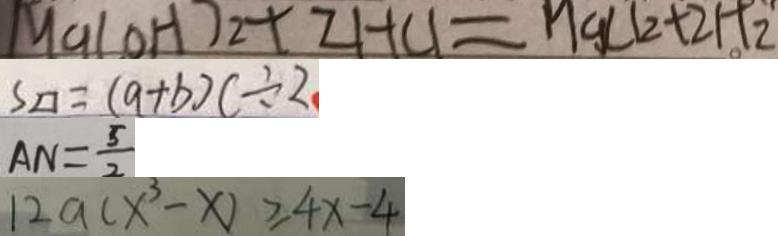<formula> <loc_0><loc_0><loc_500><loc_500>M C l ( O H ) _ { 2 } + 2 H C l = H g l _ { 2 } + 2 H _ { 2 } 
 S \square = ( a + b ) c \div 2 
 A N = \frac { 5 } { 2 } 
 1 2 a ( x ^ { 3 } - x ) \geq 4 x - 4</formula> 